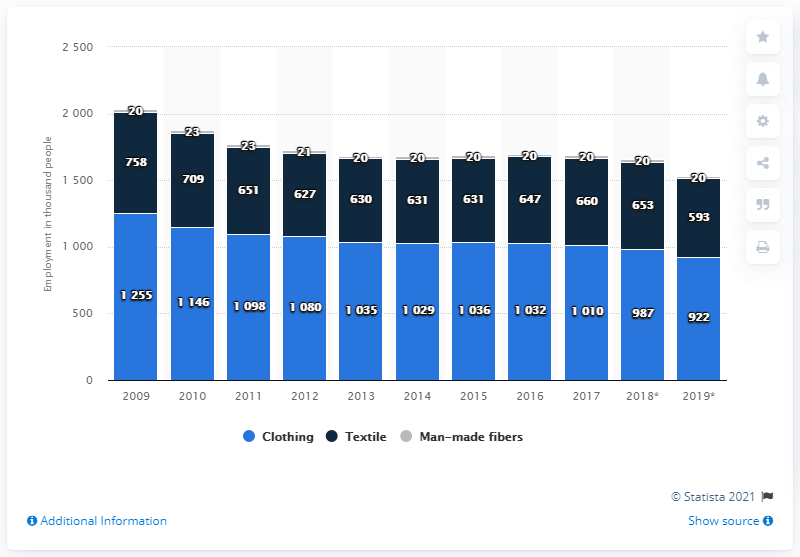Draw attention to some important aspects in this diagram. The highest value in the clothing sector has consistently been higher than the lowest value in the man-made fibers industry over the years, with a difference of 1235 or more. The employment in the textile industry was highest in the year 2009. 